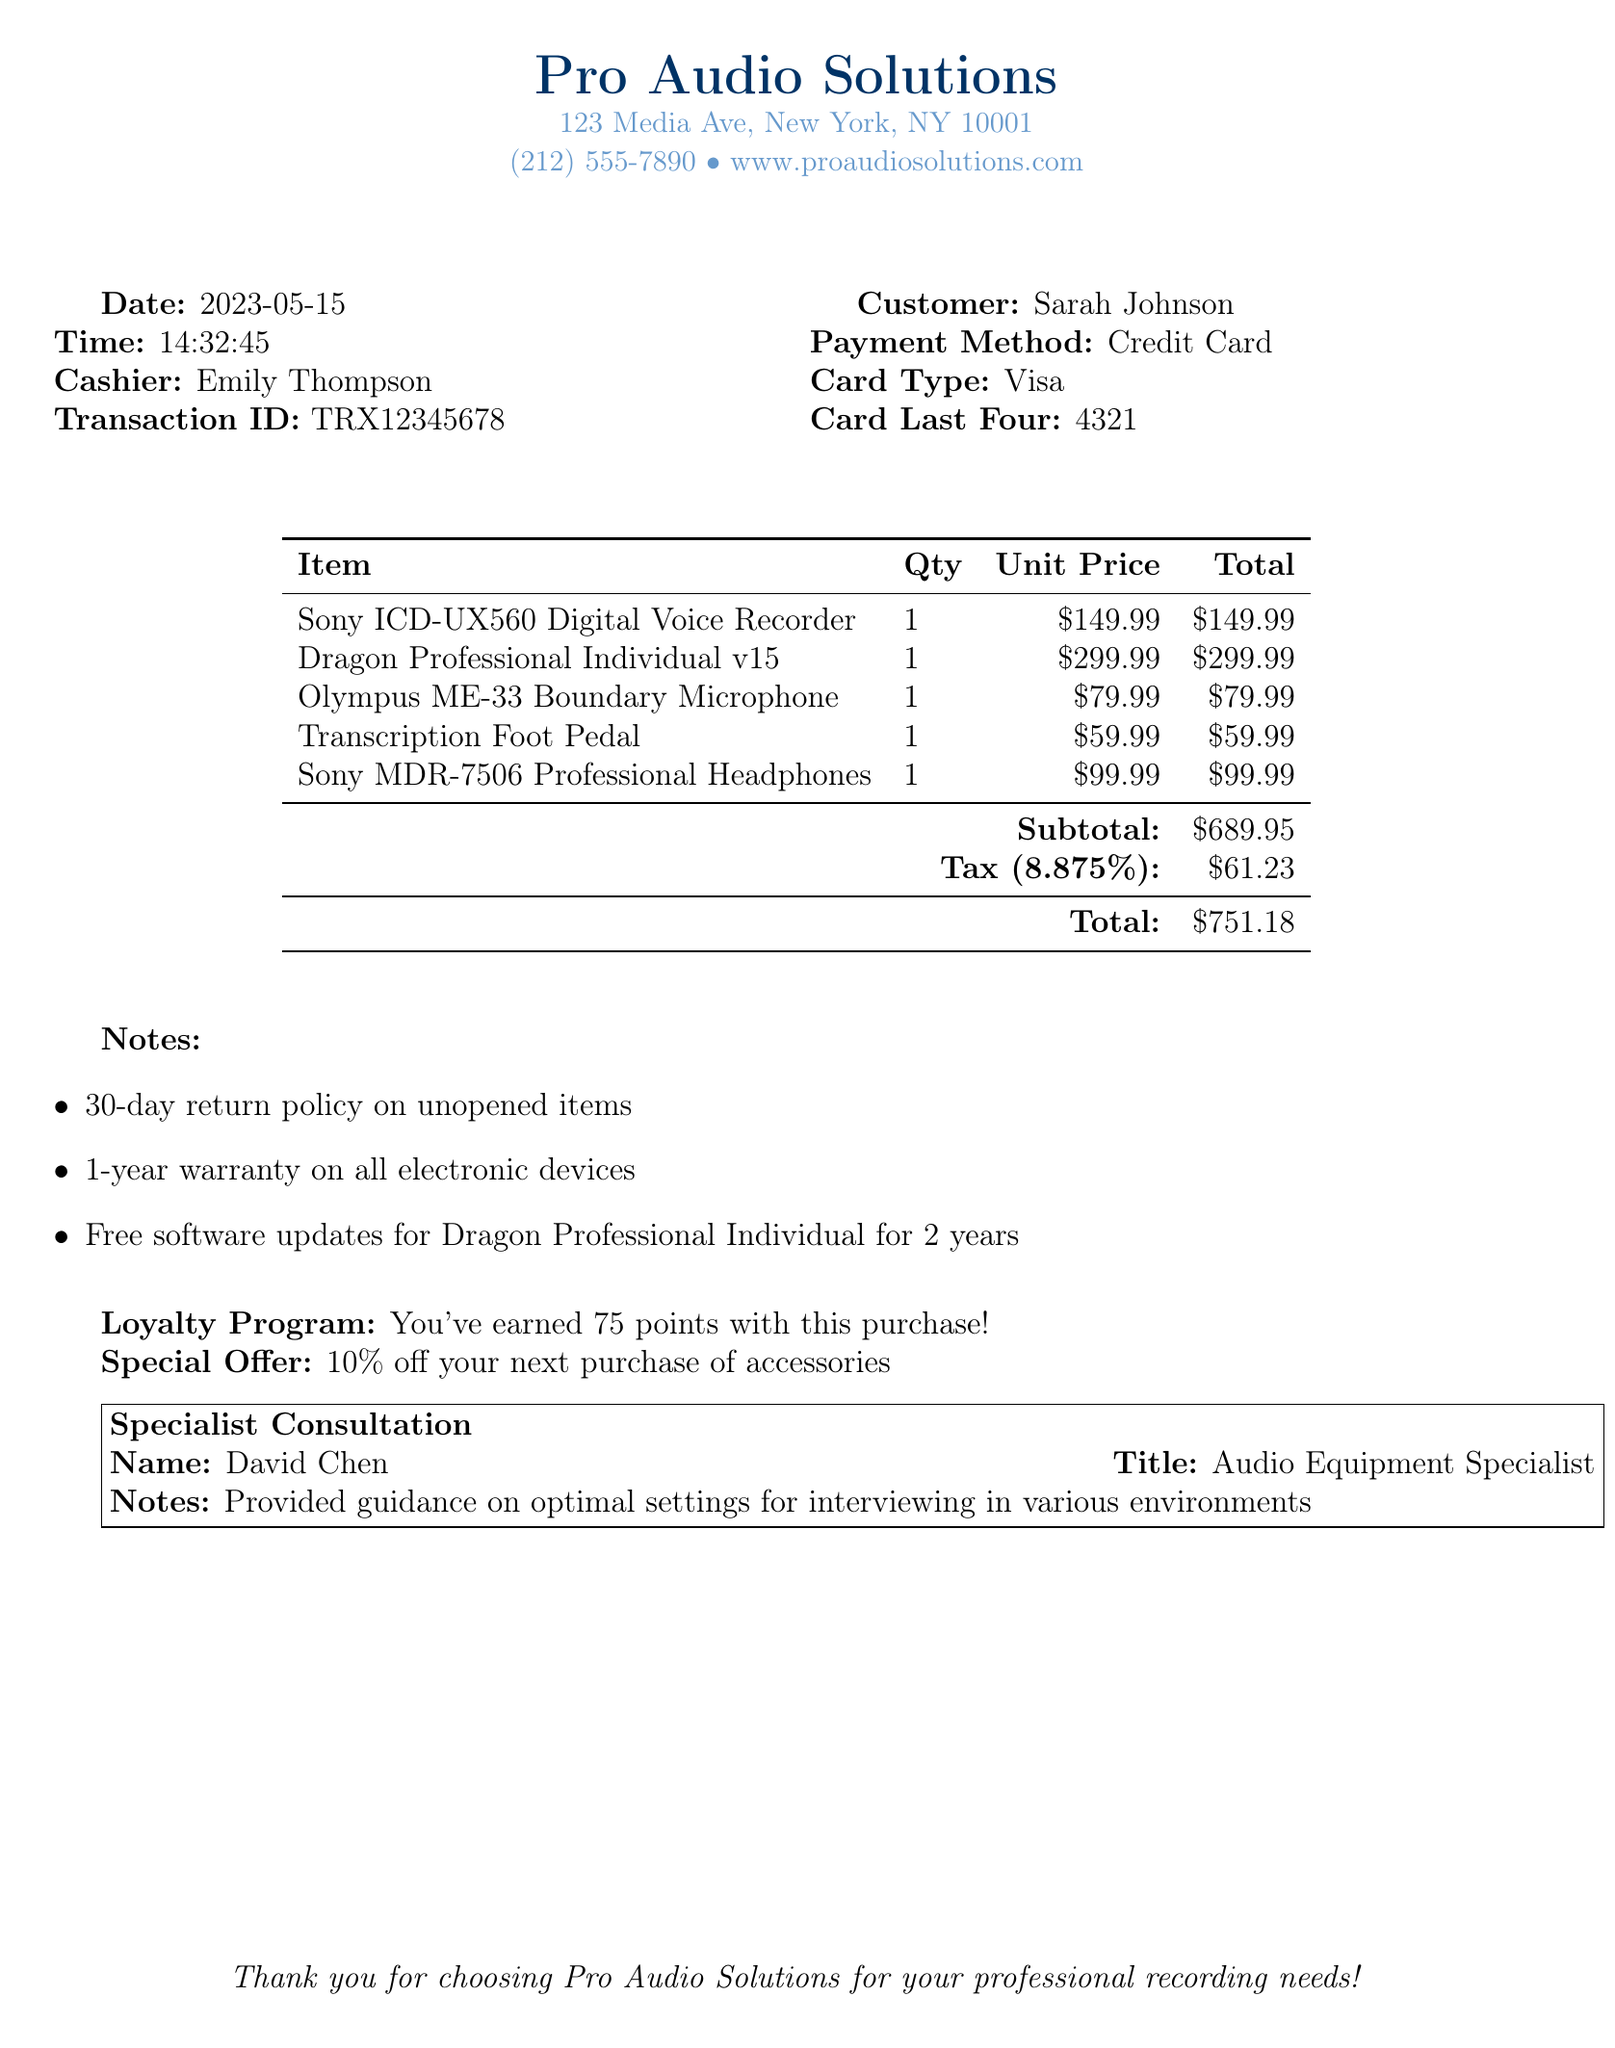what is the store name? The store name is mentioned at the top of the document as "Pro Audio Solutions".
Answer: Pro Audio Solutions who was the cashier? The cashier's name is provided in the transaction details of the document.
Answer: Emily Thompson what is the date of purchase? The date of purchase is given in the document under the date section.
Answer: 2023-05-15 what is the total amount spent? The total amount is listed at the bottom of the itemized list in the document.
Answer: $751.18 how many loyalty points were earned? The document specifies the amount of loyalty points earned with the purchase.
Answer: 75 what is the warranty period for electronic devices? The warranty period for electronic devices is mentioned in the notes section of the document.
Answer: 1-year who provided the consultation? The document names the specialist who provided guidance in the consultation section.
Answer: David Chen what type of payment was used? The payment method is clearly stated in the transaction details of the document.
Answer: Credit Card what is the promotional offer? The promotional offer is provided in the notes towards the end of the document.
Answer: 10% off your next purchase of accessories 